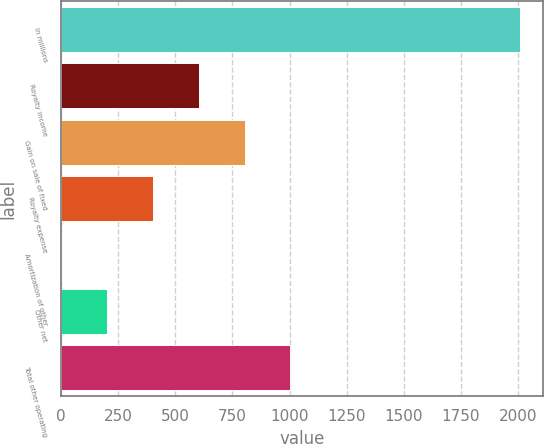Convert chart to OTSL. <chart><loc_0><loc_0><loc_500><loc_500><bar_chart><fcel>In millions<fcel>Royalty income<fcel>Gain on sale of fixed<fcel>Royalty expense<fcel>Amortization of other<fcel>Other net<fcel>Total other operating<nl><fcel>2007<fcel>602.8<fcel>803.4<fcel>402.2<fcel>1<fcel>201.6<fcel>1004<nl></chart> 